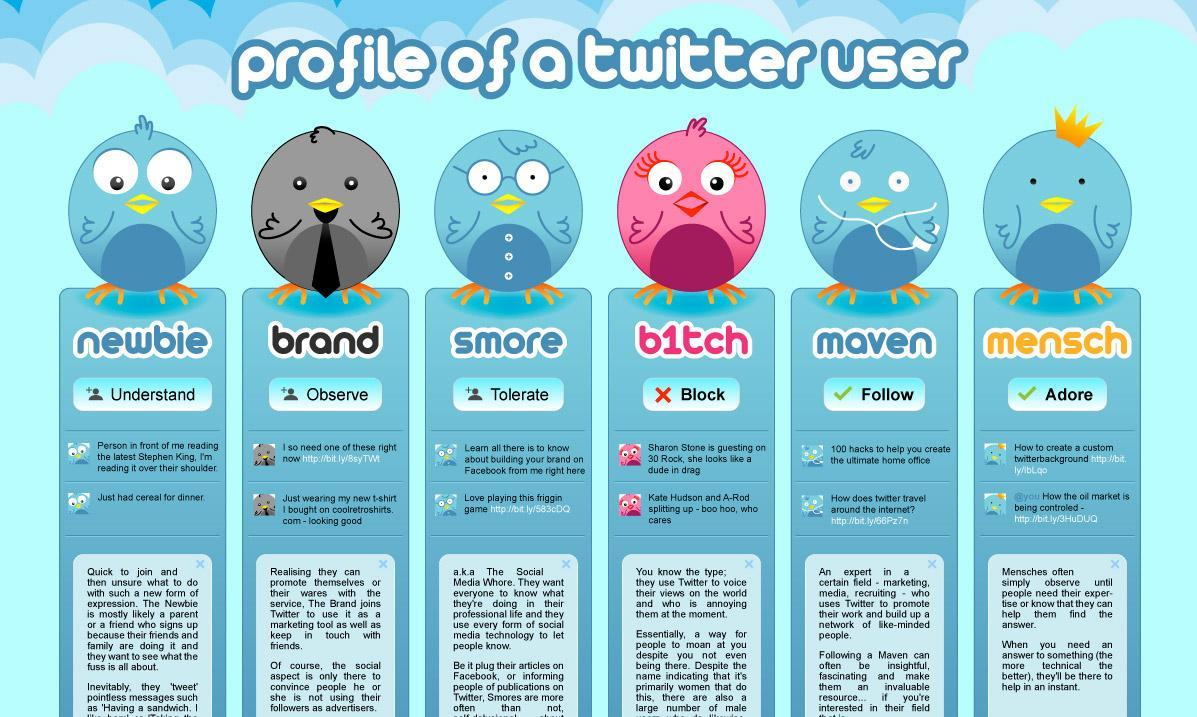How many birds with blue color in this infographic?
Answer the question with a short phrase. 4 How many options are available in the profile of a Twitter user? 6 